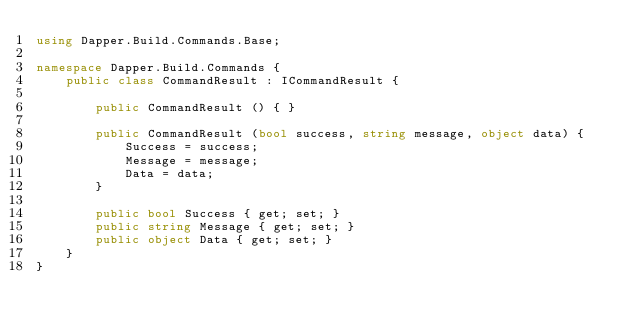<code> <loc_0><loc_0><loc_500><loc_500><_C#_>using Dapper.Build.Commands.Base;

namespace Dapper.Build.Commands {
    public class CommandResult : ICommandResult {

        public CommandResult () { }

        public CommandResult (bool success, string message, object data) {
            Success = success;
            Message = message;
            Data = data;
        }

        public bool Success { get; set; }
        public string Message { get; set; }
        public object Data { get; set; }
    }
}</code> 